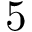<formula> <loc_0><loc_0><loc_500><loc_500>5</formula> 